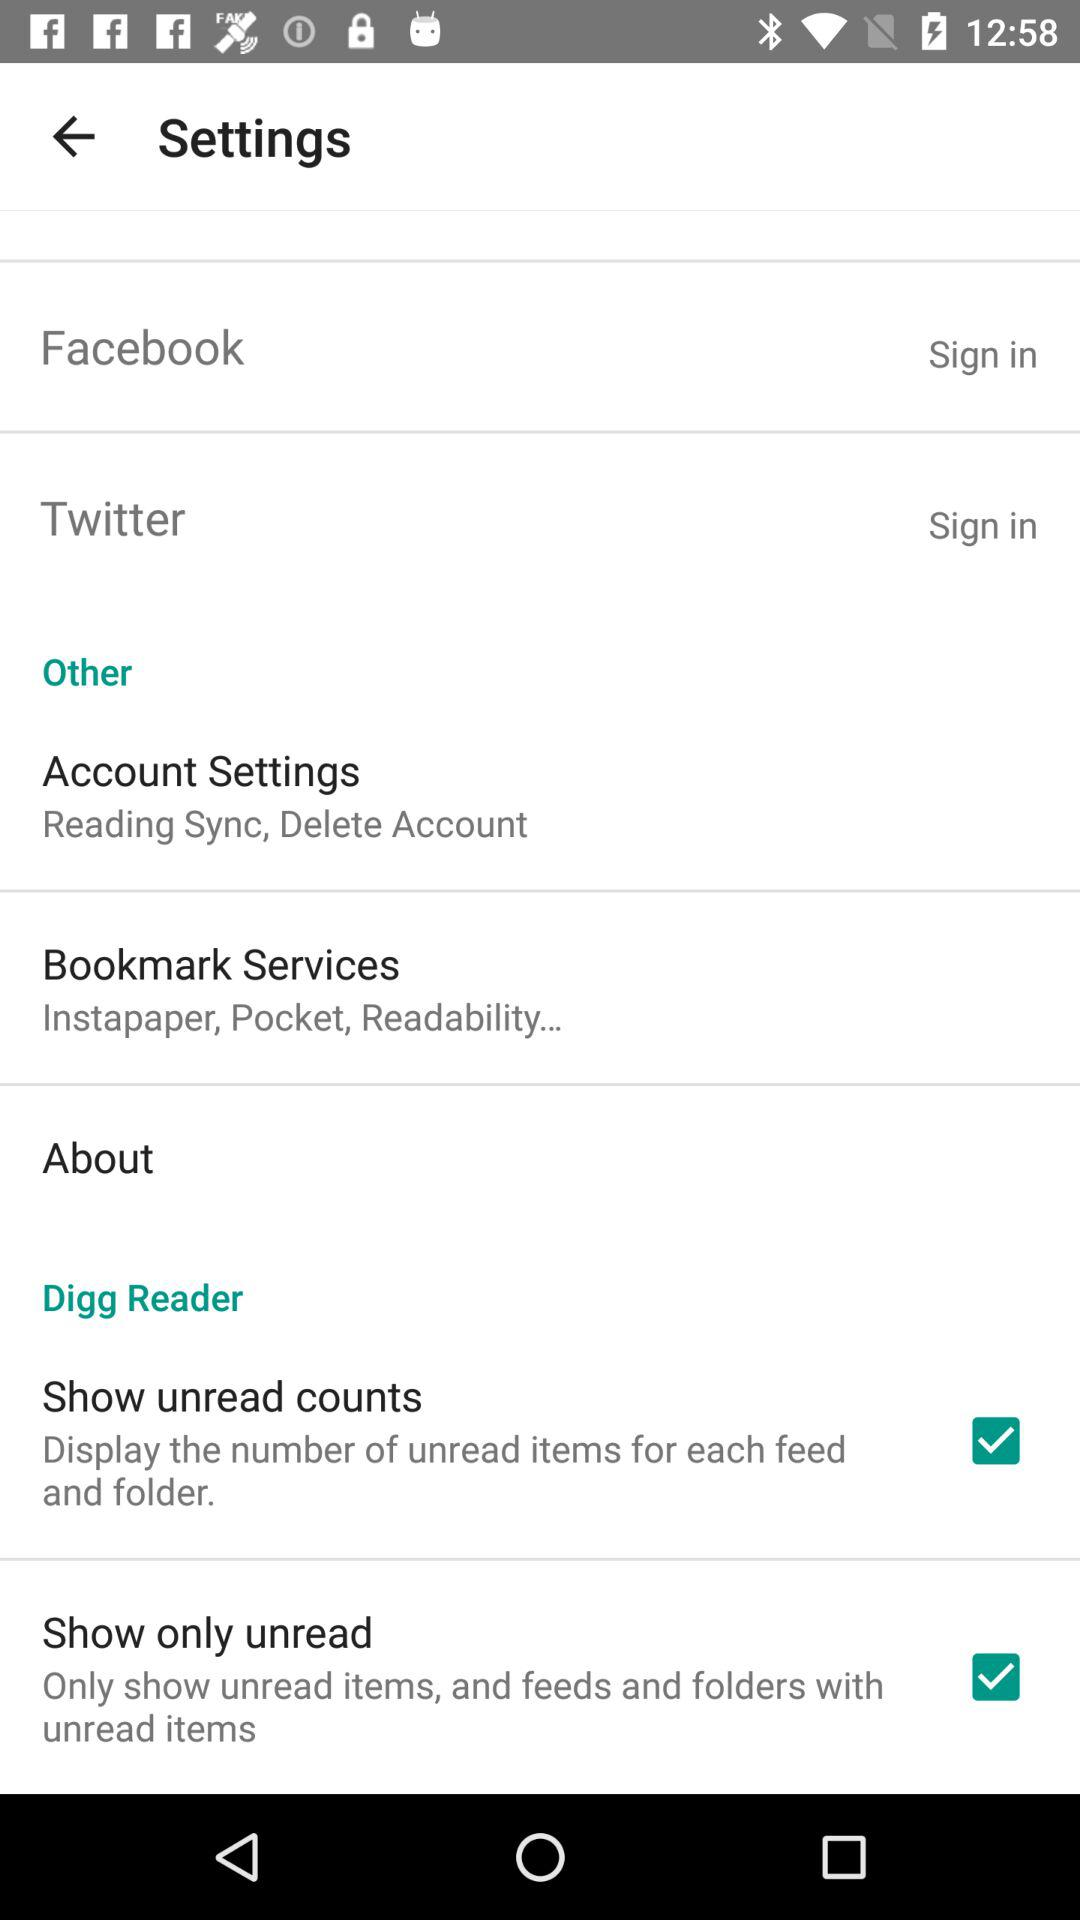What is the status of the "Show unread counts"? The status of the "Show unread counts" is "on". 